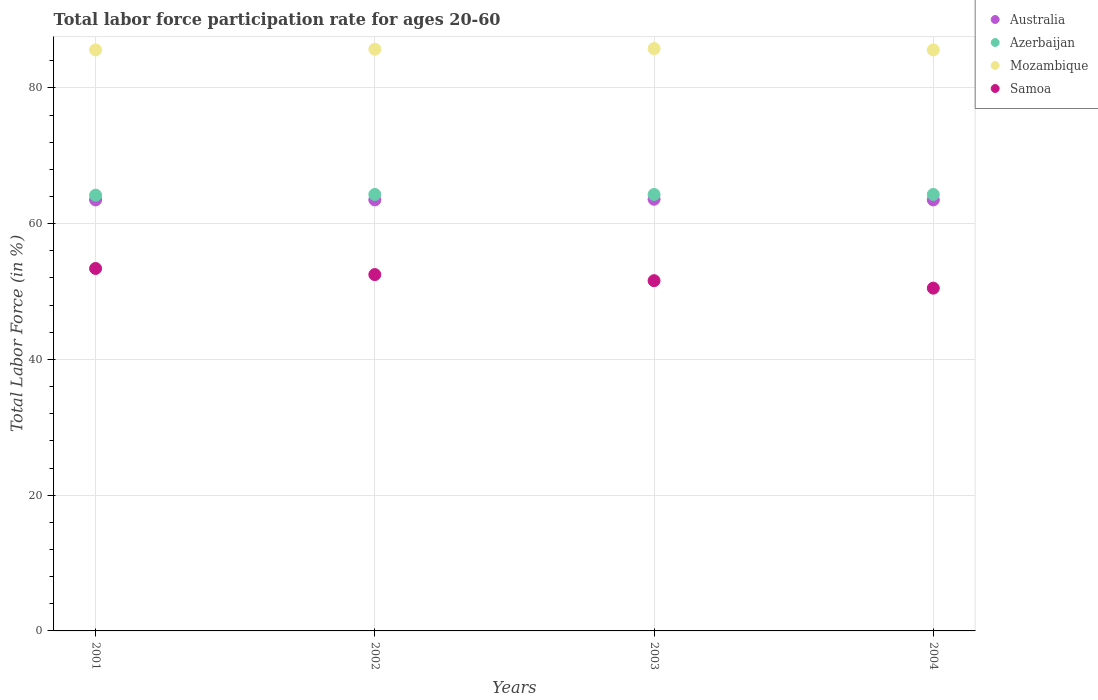How many different coloured dotlines are there?
Your answer should be very brief. 4. Is the number of dotlines equal to the number of legend labels?
Make the answer very short. Yes. What is the labor force participation rate in Australia in 2002?
Ensure brevity in your answer.  63.5. Across all years, what is the maximum labor force participation rate in Mozambique?
Offer a very short reply. 85.8. Across all years, what is the minimum labor force participation rate in Azerbaijan?
Provide a succinct answer. 64.2. In which year was the labor force participation rate in Mozambique maximum?
Offer a terse response. 2003. In which year was the labor force participation rate in Australia minimum?
Give a very brief answer. 2001. What is the total labor force participation rate in Azerbaijan in the graph?
Your response must be concise. 257.1. What is the difference between the labor force participation rate in Mozambique in 2003 and the labor force participation rate in Samoa in 2001?
Your answer should be compact. 32.4. What is the average labor force participation rate in Australia per year?
Provide a succinct answer. 63.52. In the year 2001, what is the difference between the labor force participation rate in Australia and labor force participation rate in Mozambique?
Make the answer very short. -22.1. What is the ratio of the labor force participation rate in Mozambique in 2001 to that in 2003?
Offer a terse response. 1. Is the labor force participation rate in Azerbaijan in 2002 less than that in 2004?
Offer a very short reply. No. What is the difference between the highest and the second highest labor force participation rate in Azerbaijan?
Give a very brief answer. 0. What is the difference between the highest and the lowest labor force participation rate in Azerbaijan?
Your answer should be very brief. 0.1. In how many years, is the labor force participation rate in Mozambique greater than the average labor force participation rate in Mozambique taken over all years?
Offer a terse response. 2. Is the sum of the labor force participation rate in Samoa in 2001 and 2004 greater than the maximum labor force participation rate in Australia across all years?
Provide a short and direct response. Yes. Does the labor force participation rate in Mozambique monotonically increase over the years?
Provide a succinct answer. No. Is the labor force participation rate in Mozambique strictly greater than the labor force participation rate in Australia over the years?
Ensure brevity in your answer.  Yes. Is the labor force participation rate in Mozambique strictly less than the labor force participation rate in Australia over the years?
Your response must be concise. No. How many dotlines are there?
Provide a short and direct response. 4. Does the graph contain any zero values?
Provide a short and direct response. No. Does the graph contain grids?
Keep it short and to the point. Yes. Where does the legend appear in the graph?
Provide a short and direct response. Top right. How are the legend labels stacked?
Keep it short and to the point. Vertical. What is the title of the graph?
Give a very brief answer. Total labor force participation rate for ages 20-60. What is the label or title of the Y-axis?
Ensure brevity in your answer.  Total Labor Force (in %). What is the Total Labor Force (in %) of Australia in 2001?
Give a very brief answer. 63.5. What is the Total Labor Force (in %) of Azerbaijan in 2001?
Provide a succinct answer. 64.2. What is the Total Labor Force (in %) in Mozambique in 2001?
Offer a very short reply. 85.6. What is the Total Labor Force (in %) of Samoa in 2001?
Your answer should be compact. 53.4. What is the Total Labor Force (in %) in Australia in 2002?
Offer a very short reply. 63.5. What is the Total Labor Force (in %) in Azerbaijan in 2002?
Offer a terse response. 64.3. What is the Total Labor Force (in %) of Mozambique in 2002?
Make the answer very short. 85.7. What is the Total Labor Force (in %) in Samoa in 2002?
Your response must be concise. 52.5. What is the Total Labor Force (in %) in Australia in 2003?
Keep it short and to the point. 63.6. What is the Total Labor Force (in %) in Azerbaijan in 2003?
Offer a terse response. 64.3. What is the Total Labor Force (in %) of Mozambique in 2003?
Your response must be concise. 85.8. What is the Total Labor Force (in %) of Samoa in 2003?
Provide a short and direct response. 51.6. What is the Total Labor Force (in %) in Australia in 2004?
Your answer should be compact. 63.5. What is the Total Labor Force (in %) in Azerbaijan in 2004?
Ensure brevity in your answer.  64.3. What is the Total Labor Force (in %) in Mozambique in 2004?
Your response must be concise. 85.6. What is the Total Labor Force (in %) in Samoa in 2004?
Your answer should be very brief. 50.5. Across all years, what is the maximum Total Labor Force (in %) in Australia?
Provide a short and direct response. 63.6. Across all years, what is the maximum Total Labor Force (in %) in Azerbaijan?
Your answer should be compact. 64.3. Across all years, what is the maximum Total Labor Force (in %) in Mozambique?
Your answer should be very brief. 85.8. Across all years, what is the maximum Total Labor Force (in %) of Samoa?
Your response must be concise. 53.4. Across all years, what is the minimum Total Labor Force (in %) of Australia?
Your answer should be compact. 63.5. Across all years, what is the minimum Total Labor Force (in %) of Azerbaijan?
Give a very brief answer. 64.2. Across all years, what is the minimum Total Labor Force (in %) of Mozambique?
Make the answer very short. 85.6. Across all years, what is the minimum Total Labor Force (in %) in Samoa?
Your answer should be compact. 50.5. What is the total Total Labor Force (in %) in Australia in the graph?
Ensure brevity in your answer.  254.1. What is the total Total Labor Force (in %) of Azerbaijan in the graph?
Your response must be concise. 257.1. What is the total Total Labor Force (in %) in Mozambique in the graph?
Ensure brevity in your answer.  342.7. What is the total Total Labor Force (in %) in Samoa in the graph?
Your answer should be very brief. 208. What is the difference between the Total Labor Force (in %) of Azerbaijan in 2001 and that in 2002?
Provide a succinct answer. -0.1. What is the difference between the Total Labor Force (in %) in Azerbaijan in 2001 and that in 2003?
Your response must be concise. -0.1. What is the difference between the Total Labor Force (in %) in Mozambique in 2001 and that in 2003?
Your response must be concise. -0.2. What is the difference between the Total Labor Force (in %) in Samoa in 2001 and that in 2004?
Ensure brevity in your answer.  2.9. What is the difference between the Total Labor Force (in %) in Australia in 2002 and that in 2003?
Your response must be concise. -0.1. What is the difference between the Total Labor Force (in %) of Australia in 2002 and that in 2004?
Your answer should be compact. 0. What is the difference between the Total Labor Force (in %) of Azerbaijan in 2002 and that in 2004?
Offer a terse response. 0. What is the difference between the Total Labor Force (in %) in Mozambique in 2002 and that in 2004?
Provide a short and direct response. 0.1. What is the difference between the Total Labor Force (in %) of Samoa in 2002 and that in 2004?
Ensure brevity in your answer.  2. What is the difference between the Total Labor Force (in %) in Mozambique in 2003 and that in 2004?
Your answer should be very brief. 0.2. What is the difference between the Total Labor Force (in %) of Australia in 2001 and the Total Labor Force (in %) of Mozambique in 2002?
Your answer should be compact. -22.2. What is the difference between the Total Labor Force (in %) in Azerbaijan in 2001 and the Total Labor Force (in %) in Mozambique in 2002?
Your answer should be very brief. -21.5. What is the difference between the Total Labor Force (in %) of Azerbaijan in 2001 and the Total Labor Force (in %) of Samoa in 2002?
Make the answer very short. 11.7. What is the difference between the Total Labor Force (in %) of Mozambique in 2001 and the Total Labor Force (in %) of Samoa in 2002?
Offer a terse response. 33.1. What is the difference between the Total Labor Force (in %) in Australia in 2001 and the Total Labor Force (in %) in Azerbaijan in 2003?
Give a very brief answer. -0.8. What is the difference between the Total Labor Force (in %) of Australia in 2001 and the Total Labor Force (in %) of Mozambique in 2003?
Offer a terse response. -22.3. What is the difference between the Total Labor Force (in %) in Australia in 2001 and the Total Labor Force (in %) in Samoa in 2003?
Provide a short and direct response. 11.9. What is the difference between the Total Labor Force (in %) of Azerbaijan in 2001 and the Total Labor Force (in %) of Mozambique in 2003?
Provide a succinct answer. -21.6. What is the difference between the Total Labor Force (in %) of Australia in 2001 and the Total Labor Force (in %) of Azerbaijan in 2004?
Provide a succinct answer. -0.8. What is the difference between the Total Labor Force (in %) of Australia in 2001 and the Total Labor Force (in %) of Mozambique in 2004?
Your response must be concise. -22.1. What is the difference between the Total Labor Force (in %) of Azerbaijan in 2001 and the Total Labor Force (in %) of Mozambique in 2004?
Your answer should be compact. -21.4. What is the difference between the Total Labor Force (in %) of Azerbaijan in 2001 and the Total Labor Force (in %) of Samoa in 2004?
Provide a short and direct response. 13.7. What is the difference between the Total Labor Force (in %) in Mozambique in 2001 and the Total Labor Force (in %) in Samoa in 2004?
Offer a terse response. 35.1. What is the difference between the Total Labor Force (in %) in Australia in 2002 and the Total Labor Force (in %) in Mozambique in 2003?
Provide a succinct answer. -22.3. What is the difference between the Total Labor Force (in %) in Australia in 2002 and the Total Labor Force (in %) in Samoa in 2003?
Your answer should be very brief. 11.9. What is the difference between the Total Labor Force (in %) in Azerbaijan in 2002 and the Total Labor Force (in %) in Mozambique in 2003?
Make the answer very short. -21.5. What is the difference between the Total Labor Force (in %) in Mozambique in 2002 and the Total Labor Force (in %) in Samoa in 2003?
Ensure brevity in your answer.  34.1. What is the difference between the Total Labor Force (in %) of Australia in 2002 and the Total Labor Force (in %) of Azerbaijan in 2004?
Give a very brief answer. -0.8. What is the difference between the Total Labor Force (in %) in Australia in 2002 and the Total Labor Force (in %) in Mozambique in 2004?
Offer a terse response. -22.1. What is the difference between the Total Labor Force (in %) in Azerbaijan in 2002 and the Total Labor Force (in %) in Mozambique in 2004?
Keep it short and to the point. -21.3. What is the difference between the Total Labor Force (in %) in Mozambique in 2002 and the Total Labor Force (in %) in Samoa in 2004?
Your answer should be compact. 35.2. What is the difference between the Total Labor Force (in %) in Australia in 2003 and the Total Labor Force (in %) in Azerbaijan in 2004?
Your response must be concise. -0.7. What is the difference between the Total Labor Force (in %) of Australia in 2003 and the Total Labor Force (in %) of Mozambique in 2004?
Offer a very short reply. -22. What is the difference between the Total Labor Force (in %) in Azerbaijan in 2003 and the Total Labor Force (in %) in Mozambique in 2004?
Your response must be concise. -21.3. What is the difference between the Total Labor Force (in %) in Azerbaijan in 2003 and the Total Labor Force (in %) in Samoa in 2004?
Your answer should be very brief. 13.8. What is the difference between the Total Labor Force (in %) in Mozambique in 2003 and the Total Labor Force (in %) in Samoa in 2004?
Your answer should be compact. 35.3. What is the average Total Labor Force (in %) of Australia per year?
Provide a short and direct response. 63.52. What is the average Total Labor Force (in %) of Azerbaijan per year?
Offer a very short reply. 64.28. What is the average Total Labor Force (in %) in Mozambique per year?
Your answer should be compact. 85.67. What is the average Total Labor Force (in %) in Samoa per year?
Keep it short and to the point. 52. In the year 2001, what is the difference between the Total Labor Force (in %) in Australia and Total Labor Force (in %) in Azerbaijan?
Provide a short and direct response. -0.7. In the year 2001, what is the difference between the Total Labor Force (in %) of Australia and Total Labor Force (in %) of Mozambique?
Your response must be concise. -22.1. In the year 2001, what is the difference between the Total Labor Force (in %) in Azerbaijan and Total Labor Force (in %) in Mozambique?
Keep it short and to the point. -21.4. In the year 2001, what is the difference between the Total Labor Force (in %) of Azerbaijan and Total Labor Force (in %) of Samoa?
Make the answer very short. 10.8. In the year 2001, what is the difference between the Total Labor Force (in %) of Mozambique and Total Labor Force (in %) of Samoa?
Your answer should be compact. 32.2. In the year 2002, what is the difference between the Total Labor Force (in %) in Australia and Total Labor Force (in %) in Azerbaijan?
Your answer should be very brief. -0.8. In the year 2002, what is the difference between the Total Labor Force (in %) of Australia and Total Labor Force (in %) of Mozambique?
Give a very brief answer. -22.2. In the year 2002, what is the difference between the Total Labor Force (in %) of Australia and Total Labor Force (in %) of Samoa?
Your answer should be very brief. 11. In the year 2002, what is the difference between the Total Labor Force (in %) in Azerbaijan and Total Labor Force (in %) in Mozambique?
Your answer should be compact. -21.4. In the year 2002, what is the difference between the Total Labor Force (in %) of Mozambique and Total Labor Force (in %) of Samoa?
Provide a succinct answer. 33.2. In the year 2003, what is the difference between the Total Labor Force (in %) of Australia and Total Labor Force (in %) of Azerbaijan?
Provide a succinct answer. -0.7. In the year 2003, what is the difference between the Total Labor Force (in %) in Australia and Total Labor Force (in %) in Mozambique?
Offer a terse response. -22.2. In the year 2003, what is the difference between the Total Labor Force (in %) in Azerbaijan and Total Labor Force (in %) in Mozambique?
Ensure brevity in your answer.  -21.5. In the year 2003, what is the difference between the Total Labor Force (in %) in Azerbaijan and Total Labor Force (in %) in Samoa?
Make the answer very short. 12.7. In the year 2003, what is the difference between the Total Labor Force (in %) in Mozambique and Total Labor Force (in %) in Samoa?
Your answer should be very brief. 34.2. In the year 2004, what is the difference between the Total Labor Force (in %) of Australia and Total Labor Force (in %) of Mozambique?
Your answer should be compact. -22.1. In the year 2004, what is the difference between the Total Labor Force (in %) in Australia and Total Labor Force (in %) in Samoa?
Offer a very short reply. 13. In the year 2004, what is the difference between the Total Labor Force (in %) of Azerbaijan and Total Labor Force (in %) of Mozambique?
Your answer should be very brief. -21.3. In the year 2004, what is the difference between the Total Labor Force (in %) in Mozambique and Total Labor Force (in %) in Samoa?
Make the answer very short. 35.1. What is the ratio of the Total Labor Force (in %) in Australia in 2001 to that in 2002?
Provide a succinct answer. 1. What is the ratio of the Total Labor Force (in %) in Mozambique in 2001 to that in 2002?
Offer a terse response. 1. What is the ratio of the Total Labor Force (in %) of Samoa in 2001 to that in 2002?
Provide a succinct answer. 1.02. What is the ratio of the Total Labor Force (in %) in Mozambique in 2001 to that in 2003?
Offer a terse response. 1. What is the ratio of the Total Labor Force (in %) of Samoa in 2001 to that in 2003?
Provide a short and direct response. 1.03. What is the ratio of the Total Labor Force (in %) in Australia in 2001 to that in 2004?
Keep it short and to the point. 1. What is the ratio of the Total Labor Force (in %) of Mozambique in 2001 to that in 2004?
Your answer should be compact. 1. What is the ratio of the Total Labor Force (in %) in Samoa in 2001 to that in 2004?
Offer a terse response. 1.06. What is the ratio of the Total Labor Force (in %) of Mozambique in 2002 to that in 2003?
Offer a terse response. 1. What is the ratio of the Total Labor Force (in %) of Samoa in 2002 to that in 2003?
Your response must be concise. 1.02. What is the ratio of the Total Labor Force (in %) of Australia in 2002 to that in 2004?
Offer a very short reply. 1. What is the ratio of the Total Labor Force (in %) of Azerbaijan in 2002 to that in 2004?
Your answer should be very brief. 1. What is the ratio of the Total Labor Force (in %) of Samoa in 2002 to that in 2004?
Provide a short and direct response. 1.04. What is the ratio of the Total Labor Force (in %) of Azerbaijan in 2003 to that in 2004?
Give a very brief answer. 1. What is the ratio of the Total Labor Force (in %) in Mozambique in 2003 to that in 2004?
Your answer should be very brief. 1. What is the ratio of the Total Labor Force (in %) in Samoa in 2003 to that in 2004?
Offer a terse response. 1.02. What is the difference between the highest and the second highest Total Labor Force (in %) of Australia?
Make the answer very short. 0.1. What is the difference between the highest and the second highest Total Labor Force (in %) in Mozambique?
Your response must be concise. 0.1. What is the difference between the highest and the second highest Total Labor Force (in %) of Samoa?
Make the answer very short. 0.9. What is the difference between the highest and the lowest Total Labor Force (in %) in Australia?
Your response must be concise. 0.1. What is the difference between the highest and the lowest Total Labor Force (in %) in Samoa?
Make the answer very short. 2.9. 